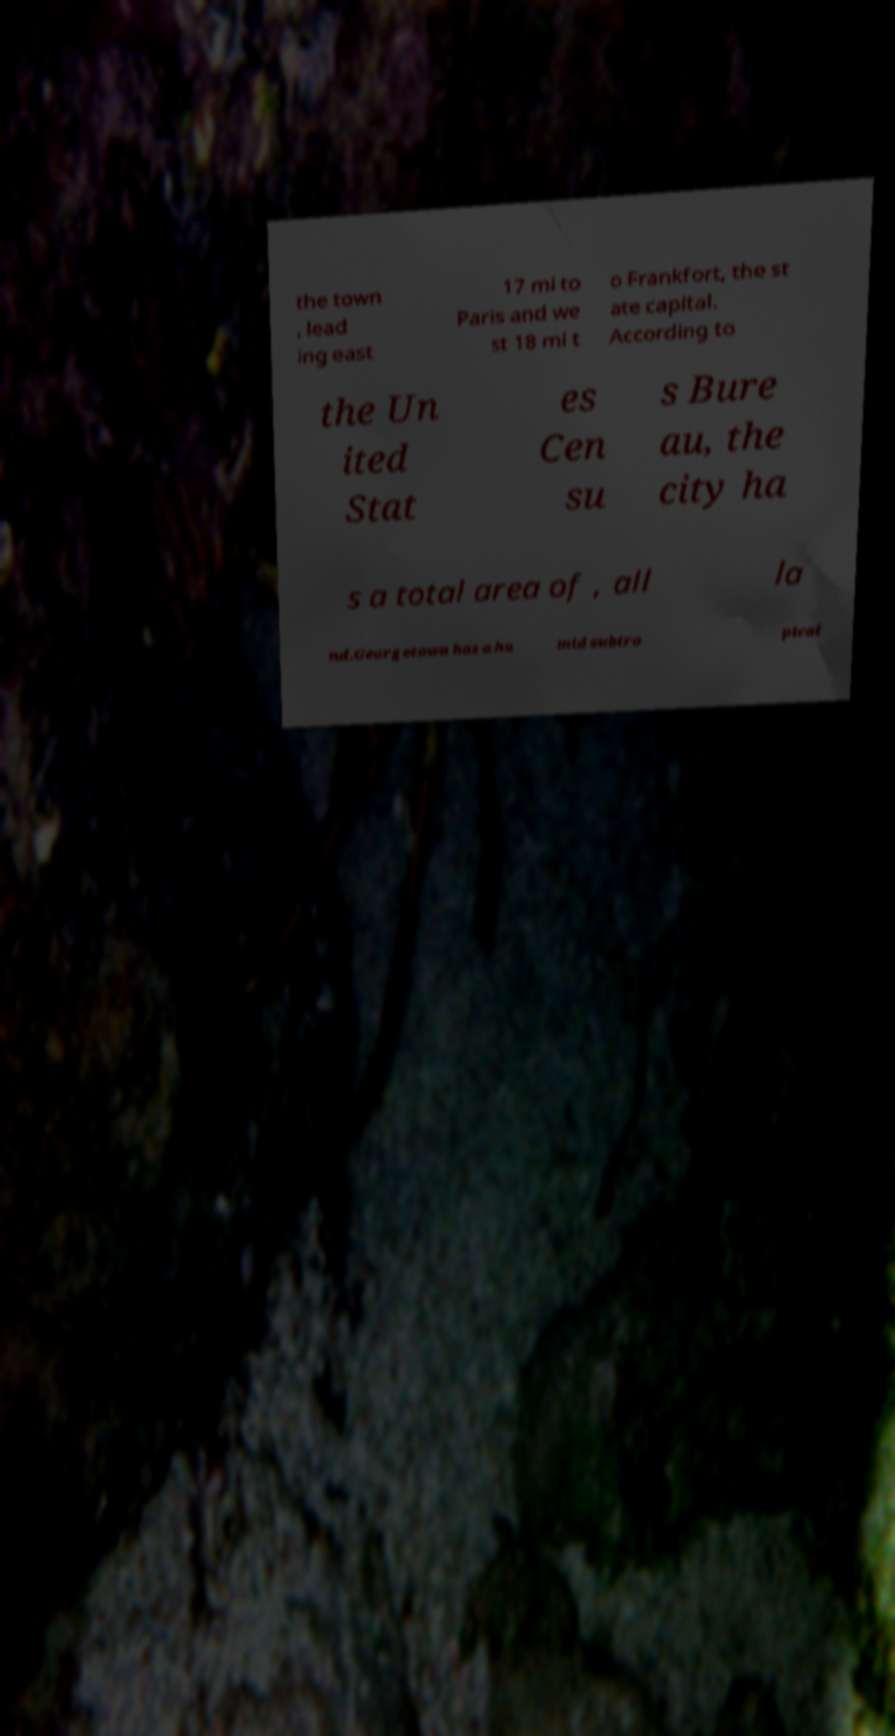I need the written content from this picture converted into text. Can you do that? the town , lead ing east 17 mi to Paris and we st 18 mi t o Frankfort, the st ate capital. According to the Un ited Stat es Cen su s Bure au, the city ha s a total area of , all la nd.Georgetown has a hu mid subtro pical 